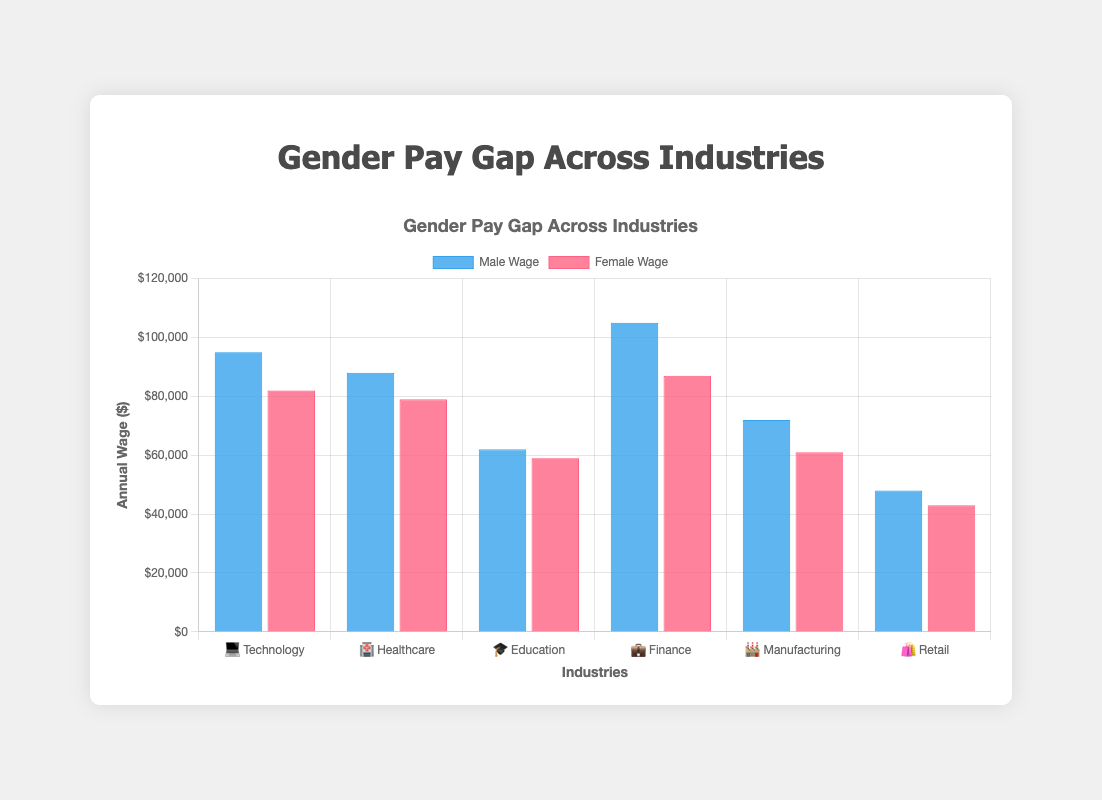What is the title of the chart? The title is prominently displayed at the top of the chart in larger font to provide context about the data visualization.
Answer: Gender Pay Gap Across Industries Which industry has the largest gender pay gap? To determine the largest gender pay gap, we compare the difference between the male and female wages across all industries. Finance shows the largest gap with male wage at $105,000 and female wage at $87,000. The difference is $18,000.
Answer: Finance What is the male wage in the Manufacturing industry? 🏭 Look for the 🏭 emoji on the x-axis, representing Manufacturing, and observe the height of the blue bar (male wage) for this industry.
Answer: $72,000 How much more do males in Technology 💻 earn compared to females in Education 🎓? Male wage in Technology is $95,000 and female wage in Education is $59,000. Subtract the female wage from the male wage: $95,000 - $59,000 = $36,000.
Answer: $36,000 What is the average female wage across all industries? Sum the female wages (82000 + 79000 + 59000 + 87000 + 61000 + 43000) = $411,000. Divide by the number of industries (6): $411,000 / 6 = $68,500.
Answer: $68,500 Which industry has the smallest gender pay gap? Compare the wage differences for each industry and find the smallest difference. Education has the smallest gap, with a difference of $3,000 ($62,000 - $59,000).
Answer: Education What is the total annual wage difference between genders in the Retail industry 🛍️? The male wage in Retail is $48,000 and the female wage is $43,000. Subtract the female wage from the male wage: $48,000 - $43,000 = $5,000.
Answer: $5,000 In which industries do males earn more than $90,000 annually? Review the male wage bars and identify the ones over $90,000. They are: Technology ($95,000) and Finance ($105,000).
Answer: Technology, Finance How much do males earn more than females across all industries combined? Sum the differences for each industry: (95000-82000) + (88000-79000) + (62000-59000) + (105000-87000) + (72000-61000) + (48000-43000) = $175,000.
Answer: $175,000 Which industry's male and female wages are closest to each other? Find the smallest wage difference between genders for each industry. Education has the closest wages, with a difference of $3,000.
Answer: Education 